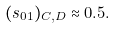Convert formula to latex. <formula><loc_0><loc_0><loc_500><loc_500>( s _ { 0 1 } ) _ { C , D } \approx 0 . 5 .</formula> 